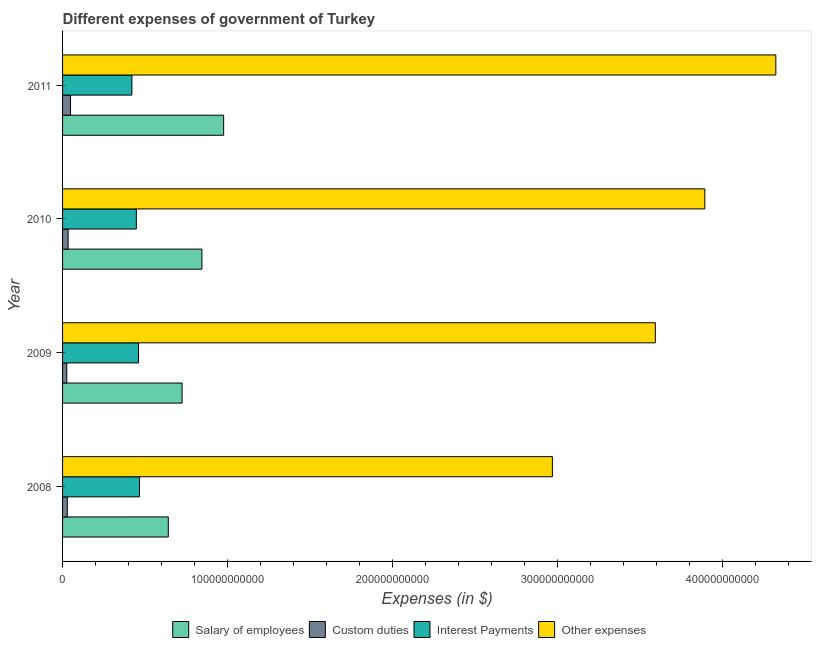How many groups of bars are there?
Your response must be concise. 4. How many bars are there on the 1st tick from the top?
Provide a short and direct response. 4. What is the label of the 2nd group of bars from the top?
Offer a very short reply. 2010. What is the amount spent on interest payments in 2009?
Keep it short and to the point. 4.60e+1. Across all years, what is the maximum amount spent on interest payments?
Give a very brief answer. 4.67e+1. Across all years, what is the minimum amount spent on salary of employees?
Keep it short and to the point. 6.41e+1. In which year was the amount spent on other expenses minimum?
Make the answer very short. 2008. What is the total amount spent on custom duties in the graph?
Provide a succinct answer. 1.36e+1. What is the difference between the amount spent on custom duties in 2009 and that in 2011?
Provide a short and direct response. -2.27e+09. What is the difference between the amount spent on interest payments in 2009 and the amount spent on salary of employees in 2011?
Offer a terse response. -5.16e+1. What is the average amount spent on other expenses per year?
Give a very brief answer. 3.69e+11. In the year 2010, what is the difference between the amount spent on other expenses and amount spent on custom duties?
Your response must be concise. 3.86e+11. In how many years, is the amount spent on other expenses greater than 300000000000 $?
Give a very brief answer. 3. What is the ratio of the amount spent on interest payments in 2009 to that in 2011?
Your response must be concise. 1.09. Is the amount spent on custom duties in 2009 less than that in 2010?
Keep it short and to the point. Yes. What is the difference between the highest and the second highest amount spent on interest payments?
Offer a very short reply. 6.15e+08. What is the difference between the highest and the lowest amount spent on salary of employees?
Give a very brief answer. 3.35e+1. What does the 4th bar from the top in 2009 represents?
Keep it short and to the point. Salary of employees. What does the 2nd bar from the bottom in 2010 represents?
Give a very brief answer. Custom duties. Is it the case that in every year, the sum of the amount spent on salary of employees and amount spent on custom duties is greater than the amount spent on interest payments?
Make the answer very short. Yes. What is the difference between two consecutive major ticks on the X-axis?
Offer a terse response. 1.00e+11. Are the values on the major ticks of X-axis written in scientific E-notation?
Make the answer very short. No. Does the graph contain any zero values?
Your answer should be very brief. No. Does the graph contain grids?
Offer a very short reply. No. Where does the legend appear in the graph?
Your answer should be very brief. Bottom center. How many legend labels are there?
Your response must be concise. 4. How are the legend labels stacked?
Offer a terse response. Horizontal. What is the title of the graph?
Provide a short and direct response. Different expenses of government of Turkey. Does "International Development Association" appear as one of the legend labels in the graph?
Ensure brevity in your answer.  No. What is the label or title of the X-axis?
Your answer should be very brief. Expenses (in $). What is the Expenses (in $) in Salary of employees in 2008?
Provide a short and direct response. 6.41e+1. What is the Expenses (in $) of Custom duties in 2008?
Ensure brevity in your answer.  2.87e+09. What is the Expenses (in $) in Interest Payments in 2008?
Keep it short and to the point. 4.67e+1. What is the Expenses (in $) of Other expenses in 2008?
Your response must be concise. 2.97e+11. What is the Expenses (in $) in Salary of employees in 2009?
Ensure brevity in your answer.  7.24e+1. What is the Expenses (in $) of Custom duties in 2009?
Your answer should be compact. 2.56e+09. What is the Expenses (in $) of Interest Payments in 2009?
Your response must be concise. 4.60e+1. What is the Expenses (in $) of Other expenses in 2009?
Keep it short and to the point. 3.59e+11. What is the Expenses (in $) in Salary of employees in 2010?
Give a very brief answer. 8.45e+1. What is the Expenses (in $) in Custom duties in 2010?
Keep it short and to the point. 3.36e+09. What is the Expenses (in $) in Interest Payments in 2010?
Your response must be concise. 4.47e+1. What is the Expenses (in $) in Other expenses in 2010?
Your answer should be very brief. 3.89e+11. What is the Expenses (in $) of Salary of employees in 2011?
Ensure brevity in your answer.  9.76e+1. What is the Expenses (in $) in Custom duties in 2011?
Make the answer very short. 4.82e+09. What is the Expenses (in $) in Interest Payments in 2011?
Your answer should be compact. 4.20e+1. What is the Expenses (in $) of Other expenses in 2011?
Ensure brevity in your answer.  4.32e+11. Across all years, what is the maximum Expenses (in $) in Salary of employees?
Your answer should be compact. 9.76e+1. Across all years, what is the maximum Expenses (in $) in Custom duties?
Give a very brief answer. 4.82e+09. Across all years, what is the maximum Expenses (in $) of Interest Payments?
Give a very brief answer. 4.67e+1. Across all years, what is the maximum Expenses (in $) in Other expenses?
Your response must be concise. 4.32e+11. Across all years, what is the minimum Expenses (in $) in Salary of employees?
Provide a succinct answer. 6.41e+1. Across all years, what is the minimum Expenses (in $) of Custom duties?
Provide a short and direct response. 2.56e+09. Across all years, what is the minimum Expenses (in $) in Interest Payments?
Offer a terse response. 4.20e+1. Across all years, what is the minimum Expenses (in $) in Other expenses?
Give a very brief answer. 2.97e+11. What is the total Expenses (in $) in Salary of employees in the graph?
Provide a short and direct response. 3.19e+11. What is the total Expenses (in $) in Custom duties in the graph?
Your answer should be compact. 1.36e+1. What is the total Expenses (in $) of Interest Payments in the graph?
Your response must be concise. 1.79e+11. What is the total Expenses (in $) of Other expenses in the graph?
Offer a very short reply. 1.48e+12. What is the difference between the Expenses (in $) of Salary of employees in 2008 and that in 2009?
Provide a succinct answer. -8.34e+09. What is the difference between the Expenses (in $) of Custom duties in 2008 and that in 2009?
Provide a succinct answer. 3.18e+08. What is the difference between the Expenses (in $) in Interest Payments in 2008 and that in 2009?
Give a very brief answer. 6.15e+08. What is the difference between the Expenses (in $) of Other expenses in 2008 and that in 2009?
Ensure brevity in your answer.  -6.24e+1. What is the difference between the Expenses (in $) of Salary of employees in 2008 and that in 2010?
Offer a very short reply. -2.04e+1. What is the difference between the Expenses (in $) of Custom duties in 2008 and that in 2010?
Offer a very short reply. -4.83e+08. What is the difference between the Expenses (in $) in Interest Payments in 2008 and that in 2010?
Provide a succinct answer. 1.95e+09. What is the difference between the Expenses (in $) in Other expenses in 2008 and that in 2010?
Give a very brief answer. -9.24e+1. What is the difference between the Expenses (in $) of Salary of employees in 2008 and that in 2011?
Ensure brevity in your answer.  -3.35e+1. What is the difference between the Expenses (in $) in Custom duties in 2008 and that in 2011?
Provide a succinct answer. -1.95e+09. What is the difference between the Expenses (in $) in Interest Payments in 2008 and that in 2011?
Your answer should be compact. 4.62e+09. What is the difference between the Expenses (in $) of Other expenses in 2008 and that in 2011?
Give a very brief answer. -1.35e+11. What is the difference between the Expenses (in $) in Salary of employees in 2009 and that in 2010?
Give a very brief answer. -1.20e+1. What is the difference between the Expenses (in $) in Custom duties in 2009 and that in 2010?
Provide a succinct answer. -8.01e+08. What is the difference between the Expenses (in $) of Interest Payments in 2009 and that in 2010?
Your response must be concise. 1.33e+09. What is the difference between the Expenses (in $) of Other expenses in 2009 and that in 2010?
Keep it short and to the point. -3.00e+1. What is the difference between the Expenses (in $) in Salary of employees in 2009 and that in 2011?
Provide a short and direct response. -2.52e+1. What is the difference between the Expenses (in $) in Custom duties in 2009 and that in 2011?
Ensure brevity in your answer.  -2.27e+09. What is the difference between the Expenses (in $) in Interest Payments in 2009 and that in 2011?
Offer a terse response. 4.01e+09. What is the difference between the Expenses (in $) in Other expenses in 2009 and that in 2011?
Give a very brief answer. -7.30e+1. What is the difference between the Expenses (in $) in Salary of employees in 2010 and that in 2011?
Give a very brief answer. -1.32e+1. What is the difference between the Expenses (in $) in Custom duties in 2010 and that in 2011?
Offer a very short reply. -1.46e+09. What is the difference between the Expenses (in $) in Interest Payments in 2010 and that in 2011?
Ensure brevity in your answer.  2.68e+09. What is the difference between the Expenses (in $) of Other expenses in 2010 and that in 2011?
Your answer should be very brief. -4.30e+1. What is the difference between the Expenses (in $) in Salary of employees in 2008 and the Expenses (in $) in Custom duties in 2009?
Offer a very short reply. 6.15e+1. What is the difference between the Expenses (in $) of Salary of employees in 2008 and the Expenses (in $) of Interest Payments in 2009?
Your answer should be very brief. 1.80e+1. What is the difference between the Expenses (in $) in Salary of employees in 2008 and the Expenses (in $) in Other expenses in 2009?
Provide a succinct answer. -2.95e+11. What is the difference between the Expenses (in $) in Custom duties in 2008 and the Expenses (in $) in Interest Payments in 2009?
Give a very brief answer. -4.32e+1. What is the difference between the Expenses (in $) of Custom duties in 2008 and the Expenses (in $) of Other expenses in 2009?
Your answer should be very brief. -3.56e+11. What is the difference between the Expenses (in $) in Interest Payments in 2008 and the Expenses (in $) in Other expenses in 2009?
Keep it short and to the point. -3.13e+11. What is the difference between the Expenses (in $) in Salary of employees in 2008 and the Expenses (in $) in Custom duties in 2010?
Provide a succinct answer. 6.07e+1. What is the difference between the Expenses (in $) of Salary of employees in 2008 and the Expenses (in $) of Interest Payments in 2010?
Provide a succinct answer. 1.94e+1. What is the difference between the Expenses (in $) in Salary of employees in 2008 and the Expenses (in $) in Other expenses in 2010?
Make the answer very short. -3.25e+11. What is the difference between the Expenses (in $) of Custom duties in 2008 and the Expenses (in $) of Interest Payments in 2010?
Keep it short and to the point. -4.18e+1. What is the difference between the Expenses (in $) in Custom duties in 2008 and the Expenses (in $) in Other expenses in 2010?
Your answer should be very brief. -3.86e+11. What is the difference between the Expenses (in $) in Interest Payments in 2008 and the Expenses (in $) in Other expenses in 2010?
Your answer should be compact. -3.43e+11. What is the difference between the Expenses (in $) of Salary of employees in 2008 and the Expenses (in $) of Custom duties in 2011?
Provide a short and direct response. 5.93e+1. What is the difference between the Expenses (in $) in Salary of employees in 2008 and the Expenses (in $) in Interest Payments in 2011?
Ensure brevity in your answer.  2.21e+1. What is the difference between the Expenses (in $) of Salary of employees in 2008 and the Expenses (in $) of Other expenses in 2011?
Provide a short and direct response. -3.68e+11. What is the difference between the Expenses (in $) in Custom duties in 2008 and the Expenses (in $) in Interest Payments in 2011?
Offer a terse response. -3.92e+1. What is the difference between the Expenses (in $) of Custom duties in 2008 and the Expenses (in $) of Other expenses in 2011?
Offer a terse response. -4.29e+11. What is the difference between the Expenses (in $) in Interest Payments in 2008 and the Expenses (in $) in Other expenses in 2011?
Provide a short and direct response. -3.86e+11. What is the difference between the Expenses (in $) of Salary of employees in 2009 and the Expenses (in $) of Custom duties in 2010?
Offer a very short reply. 6.91e+1. What is the difference between the Expenses (in $) of Salary of employees in 2009 and the Expenses (in $) of Interest Payments in 2010?
Provide a succinct answer. 2.77e+1. What is the difference between the Expenses (in $) in Salary of employees in 2009 and the Expenses (in $) in Other expenses in 2010?
Your response must be concise. -3.17e+11. What is the difference between the Expenses (in $) of Custom duties in 2009 and the Expenses (in $) of Interest Payments in 2010?
Provide a succinct answer. -4.21e+1. What is the difference between the Expenses (in $) in Custom duties in 2009 and the Expenses (in $) in Other expenses in 2010?
Your answer should be compact. -3.87e+11. What is the difference between the Expenses (in $) of Interest Payments in 2009 and the Expenses (in $) of Other expenses in 2010?
Give a very brief answer. -3.43e+11. What is the difference between the Expenses (in $) of Salary of employees in 2009 and the Expenses (in $) of Custom duties in 2011?
Ensure brevity in your answer.  6.76e+1. What is the difference between the Expenses (in $) of Salary of employees in 2009 and the Expenses (in $) of Interest Payments in 2011?
Provide a succinct answer. 3.04e+1. What is the difference between the Expenses (in $) of Salary of employees in 2009 and the Expenses (in $) of Other expenses in 2011?
Make the answer very short. -3.60e+11. What is the difference between the Expenses (in $) of Custom duties in 2009 and the Expenses (in $) of Interest Payments in 2011?
Your answer should be compact. -3.95e+1. What is the difference between the Expenses (in $) of Custom duties in 2009 and the Expenses (in $) of Other expenses in 2011?
Give a very brief answer. -4.30e+11. What is the difference between the Expenses (in $) of Interest Payments in 2009 and the Expenses (in $) of Other expenses in 2011?
Offer a very short reply. -3.86e+11. What is the difference between the Expenses (in $) of Salary of employees in 2010 and the Expenses (in $) of Custom duties in 2011?
Your answer should be very brief. 7.96e+1. What is the difference between the Expenses (in $) in Salary of employees in 2010 and the Expenses (in $) in Interest Payments in 2011?
Provide a succinct answer. 4.24e+1. What is the difference between the Expenses (in $) of Salary of employees in 2010 and the Expenses (in $) of Other expenses in 2011?
Make the answer very short. -3.48e+11. What is the difference between the Expenses (in $) of Custom duties in 2010 and the Expenses (in $) of Interest Payments in 2011?
Keep it short and to the point. -3.87e+1. What is the difference between the Expenses (in $) of Custom duties in 2010 and the Expenses (in $) of Other expenses in 2011?
Give a very brief answer. -4.29e+11. What is the difference between the Expenses (in $) of Interest Payments in 2010 and the Expenses (in $) of Other expenses in 2011?
Give a very brief answer. -3.88e+11. What is the average Expenses (in $) of Salary of employees per year?
Ensure brevity in your answer.  7.97e+1. What is the average Expenses (in $) in Custom duties per year?
Make the answer very short. 3.40e+09. What is the average Expenses (in $) of Interest Payments per year?
Provide a short and direct response. 4.49e+1. What is the average Expenses (in $) in Other expenses per year?
Offer a terse response. 3.69e+11. In the year 2008, what is the difference between the Expenses (in $) in Salary of employees and Expenses (in $) in Custom duties?
Give a very brief answer. 6.12e+1. In the year 2008, what is the difference between the Expenses (in $) of Salary of employees and Expenses (in $) of Interest Payments?
Offer a very short reply. 1.74e+1. In the year 2008, what is the difference between the Expenses (in $) in Salary of employees and Expenses (in $) in Other expenses?
Provide a succinct answer. -2.33e+11. In the year 2008, what is the difference between the Expenses (in $) in Custom duties and Expenses (in $) in Interest Payments?
Make the answer very short. -4.38e+1. In the year 2008, what is the difference between the Expenses (in $) in Custom duties and Expenses (in $) in Other expenses?
Offer a terse response. -2.94e+11. In the year 2008, what is the difference between the Expenses (in $) of Interest Payments and Expenses (in $) of Other expenses?
Your answer should be compact. -2.50e+11. In the year 2009, what is the difference between the Expenses (in $) in Salary of employees and Expenses (in $) in Custom duties?
Your response must be concise. 6.99e+1. In the year 2009, what is the difference between the Expenses (in $) of Salary of employees and Expenses (in $) of Interest Payments?
Your answer should be compact. 2.64e+1. In the year 2009, what is the difference between the Expenses (in $) in Salary of employees and Expenses (in $) in Other expenses?
Ensure brevity in your answer.  -2.87e+11. In the year 2009, what is the difference between the Expenses (in $) of Custom duties and Expenses (in $) of Interest Payments?
Give a very brief answer. -4.35e+1. In the year 2009, what is the difference between the Expenses (in $) in Custom duties and Expenses (in $) in Other expenses?
Your response must be concise. -3.57e+11. In the year 2009, what is the difference between the Expenses (in $) of Interest Payments and Expenses (in $) of Other expenses?
Offer a very short reply. -3.13e+11. In the year 2010, what is the difference between the Expenses (in $) of Salary of employees and Expenses (in $) of Custom duties?
Offer a terse response. 8.11e+1. In the year 2010, what is the difference between the Expenses (in $) in Salary of employees and Expenses (in $) in Interest Payments?
Offer a very short reply. 3.98e+1. In the year 2010, what is the difference between the Expenses (in $) in Salary of employees and Expenses (in $) in Other expenses?
Ensure brevity in your answer.  -3.05e+11. In the year 2010, what is the difference between the Expenses (in $) of Custom duties and Expenses (in $) of Interest Payments?
Give a very brief answer. -4.13e+1. In the year 2010, what is the difference between the Expenses (in $) in Custom duties and Expenses (in $) in Other expenses?
Your answer should be compact. -3.86e+11. In the year 2010, what is the difference between the Expenses (in $) of Interest Payments and Expenses (in $) of Other expenses?
Ensure brevity in your answer.  -3.45e+11. In the year 2011, what is the difference between the Expenses (in $) of Salary of employees and Expenses (in $) of Custom duties?
Make the answer very short. 9.28e+1. In the year 2011, what is the difference between the Expenses (in $) of Salary of employees and Expenses (in $) of Interest Payments?
Give a very brief answer. 5.56e+1. In the year 2011, what is the difference between the Expenses (in $) in Salary of employees and Expenses (in $) in Other expenses?
Your answer should be compact. -3.35e+11. In the year 2011, what is the difference between the Expenses (in $) of Custom duties and Expenses (in $) of Interest Payments?
Your response must be concise. -3.72e+1. In the year 2011, what is the difference between the Expenses (in $) in Custom duties and Expenses (in $) in Other expenses?
Your response must be concise. -4.27e+11. In the year 2011, what is the difference between the Expenses (in $) in Interest Payments and Expenses (in $) in Other expenses?
Keep it short and to the point. -3.90e+11. What is the ratio of the Expenses (in $) of Salary of employees in 2008 to that in 2009?
Offer a very short reply. 0.88. What is the ratio of the Expenses (in $) of Custom duties in 2008 to that in 2009?
Keep it short and to the point. 1.12. What is the ratio of the Expenses (in $) in Interest Payments in 2008 to that in 2009?
Keep it short and to the point. 1.01. What is the ratio of the Expenses (in $) in Other expenses in 2008 to that in 2009?
Your answer should be very brief. 0.83. What is the ratio of the Expenses (in $) in Salary of employees in 2008 to that in 2010?
Your response must be concise. 0.76. What is the ratio of the Expenses (in $) of Custom duties in 2008 to that in 2010?
Provide a succinct answer. 0.86. What is the ratio of the Expenses (in $) of Interest Payments in 2008 to that in 2010?
Your response must be concise. 1.04. What is the ratio of the Expenses (in $) in Other expenses in 2008 to that in 2010?
Keep it short and to the point. 0.76. What is the ratio of the Expenses (in $) in Salary of employees in 2008 to that in 2011?
Provide a short and direct response. 0.66. What is the ratio of the Expenses (in $) in Custom duties in 2008 to that in 2011?
Offer a terse response. 0.6. What is the ratio of the Expenses (in $) of Interest Payments in 2008 to that in 2011?
Your answer should be compact. 1.11. What is the ratio of the Expenses (in $) of Other expenses in 2008 to that in 2011?
Provide a succinct answer. 0.69. What is the ratio of the Expenses (in $) of Salary of employees in 2009 to that in 2010?
Provide a short and direct response. 0.86. What is the ratio of the Expenses (in $) in Custom duties in 2009 to that in 2010?
Keep it short and to the point. 0.76. What is the ratio of the Expenses (in $) in Interest Payments in 2009 to that in 2010?
Provide a succinct answer. 1.03. What is the ratio of the Expenses (in $) in Other expenses in 2009 to that in 2010?
Your answer should be very brief. 0.92. What is the ratio of the Expenses (in $) in Salary of employees in 2009 to that in 2011?
Give a very brief answer. 0.74. What is the ratio of the Expenses (in $) of Custom duties in 2009 to that in 2011?
Your response must be concise. 0.53. What is the ratio of the Expenses (in $) in Interest Payments in 2009 to that in 2011?
Your answer should be very brief. 1.1. What is the ratio of the Expenses (in $) in Other expenses in 2009 to that in 2011?
Keep it short and to the point. 0.83. What is the ratio of the Expenses (in $) in Salary of employees in 2010 to that in 2011?
Provide a succinct answer. 0.87. What is the ratio of the Expenses (in $) in Custom duties in 2010 to that in 2011?
Your answer should be compact. 0.7. What is the ratio of the Expenses (in $) in Interest Payments in 2010 to that in 2011?
Your answer should be very brief. 1.06. What is the ratio of the Expenses (in $) of Other expenses in 2010 to that in 2011?
Keep it short and to the point. 0.9. What is the difference between the highest and the second highest Expenses (in $) in Salary of employees?
Offer a terse response. 1.32e+1. What is the difference between the highest and the second highest Expenses (in $) in Custom duties?
Your answer should be very brief. 1.46e+09. What is the difference between the highest and the second highest Expenses (in $) of Interest Payments?
Give a very brief answer. 6.15e+08. What is the difference between the highest and the second highest Expenses (in $) of Other expenses?
Offer a very short reply. 4.30e+1. What is the difference between the highest and the lowest Expenses (in $) in Salary of employees?
Provide a short and direct response. 3.35e+1. What is the difference between the highest and the lowest Expenses (in $) of Custom duties?
Make the answer very short. 2.27e+09. What is the difference between the highest and the lowest Expenses (in $) of Interest Payments?
Your answer should be very brief. 4.62e+09. What is the difference between the highest and the lowest Expenses (in $) of Other expenses?
Provide a succinct answer. 1.35e+11. 